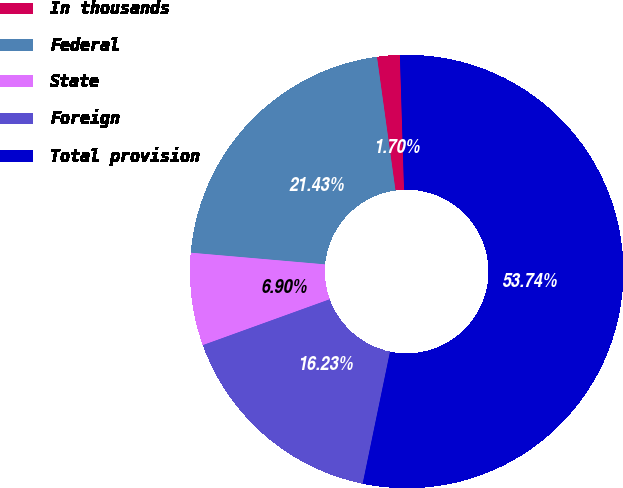<chart> <loc_0><loc_0><loc_500><loc_500><pie_chart><fcel>In thousands<fcel>Federal<fcel>State<fcel>Foreign<fcel>Total provision<nl><fcel>1.7%<fcel>21.43%<fcel>6.9%<fcel>16.23%<fcel>53.75%<nl></chart> 